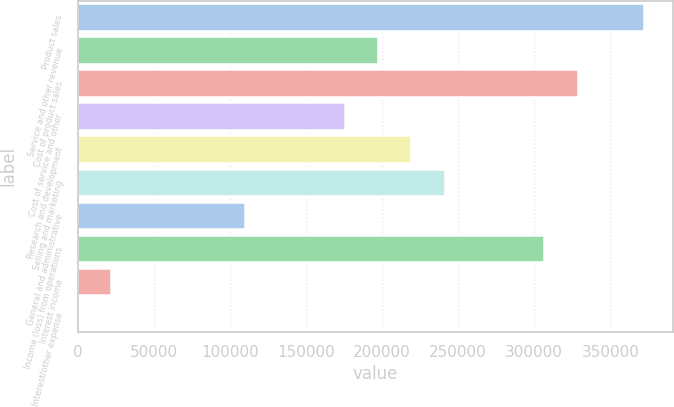<chart> <loc_0><loc_0><loc_500><loc_500><bar_chart><fcel>Product sales<fcel>Service and other revenue<fcel>Cost of product sales<fcel>Cost of service and other<fcel>Research and development<fcel>Selling and marketing<fcel>General and administrative<fcel>Income (loss) from operations<fcel>Interest income<fcel>Interest/other expense<nl><fcel>372388<fcel>197253<fcel>328604<fcel>175361<fcel>219145<fcel>241037<fcel>109686<fcel>306712<fcel>22118.8<fcel>227<nl></chart> 